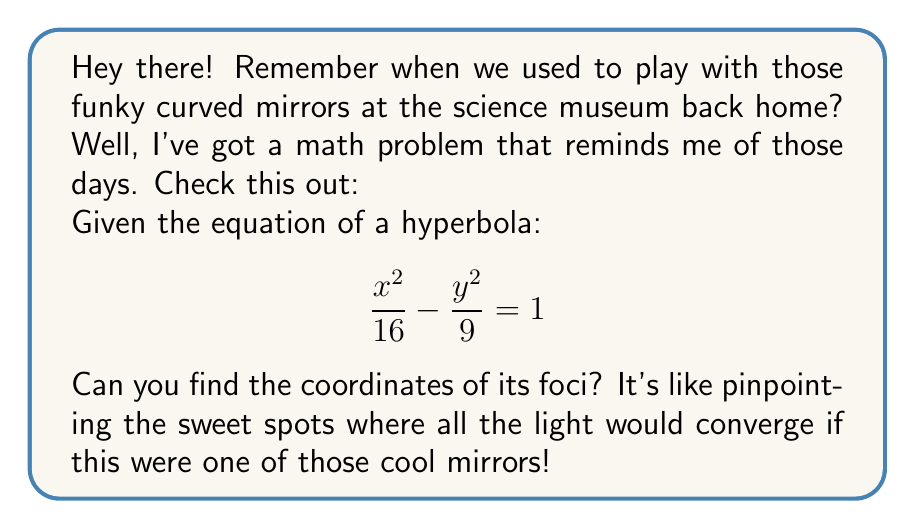Help me with this question. Sure thing! Let's break this down step-by-step:

1) First, we need to identify the standard form of the hyperbola equation:
   $$\frac{x^2}{a^2} - \frac{y^2}{b^2} = 1$$

2) From our given equation, we can see that:
   $a^2 = 16$ and $b^2 = 9$

3) Therefore:
   $a = 4$ and $b = 3$

4) For a hyperbola, the distance from the center to a focus is given by $c$, where:
   $$c^2 = a^2 + b^2$$

5) Let's calculate $c$:
   $$c^2 = 4^2 + 3^2 = 16 + 9 = 25$$
   $$c = 5$$

6) The center of this hyperbola is at (0,0) because there are no x or y terms outside the fractions in the equation.

7) For a hyperbola with its transverse axis along the x-axis (which is our case because $\frac{x^2}{a^2}$ is positive), the foci are located at (±c, 0).

Therefore, the coordinates of the foci are (5, 0) and (-5, 0).
Answer: (5, 0) and (-5, 0) 